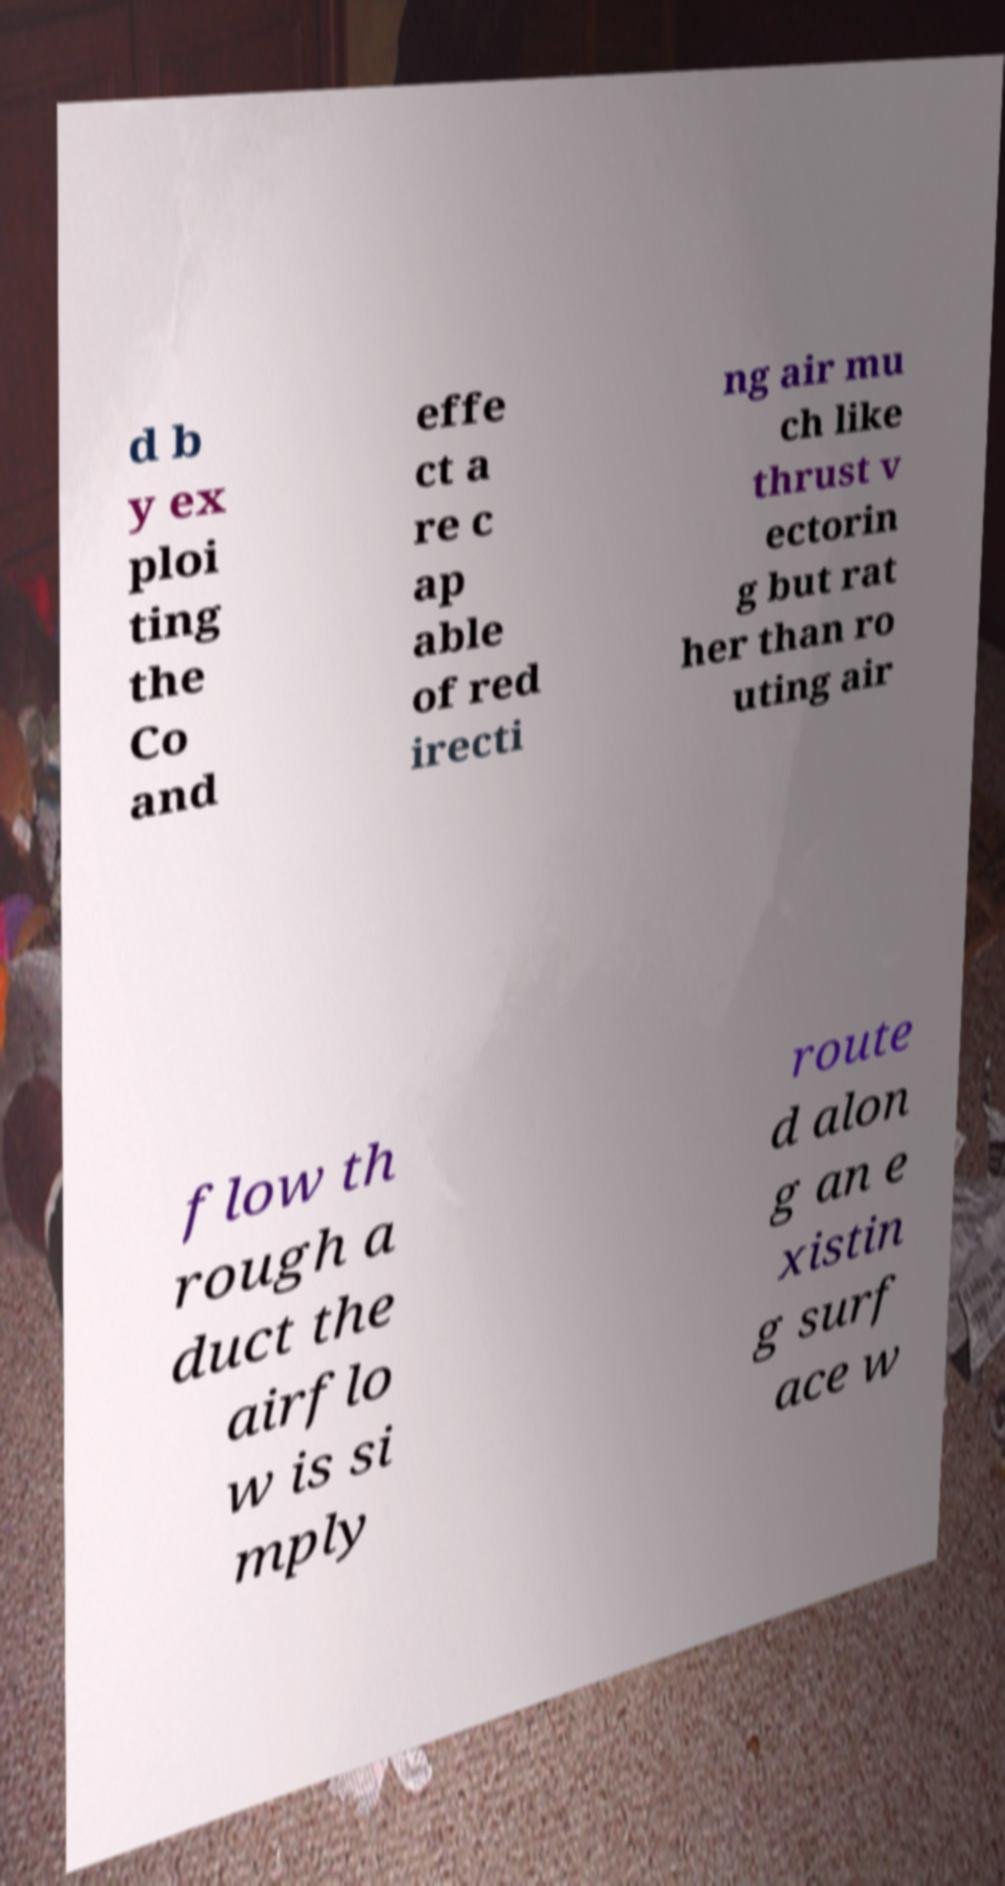Can you read and provide the text displayed in the image?This photo seems to have some interesting text. Can you extract and type it out for me? d b y ex ploi ting the Co and effe ct a re c ap able of red irecti ng air mu ch like thrust v ectorin g but rat her than ro uting air flow th rough a duct the airflo w is si mply route d alon g an e xistin g surf ace w 